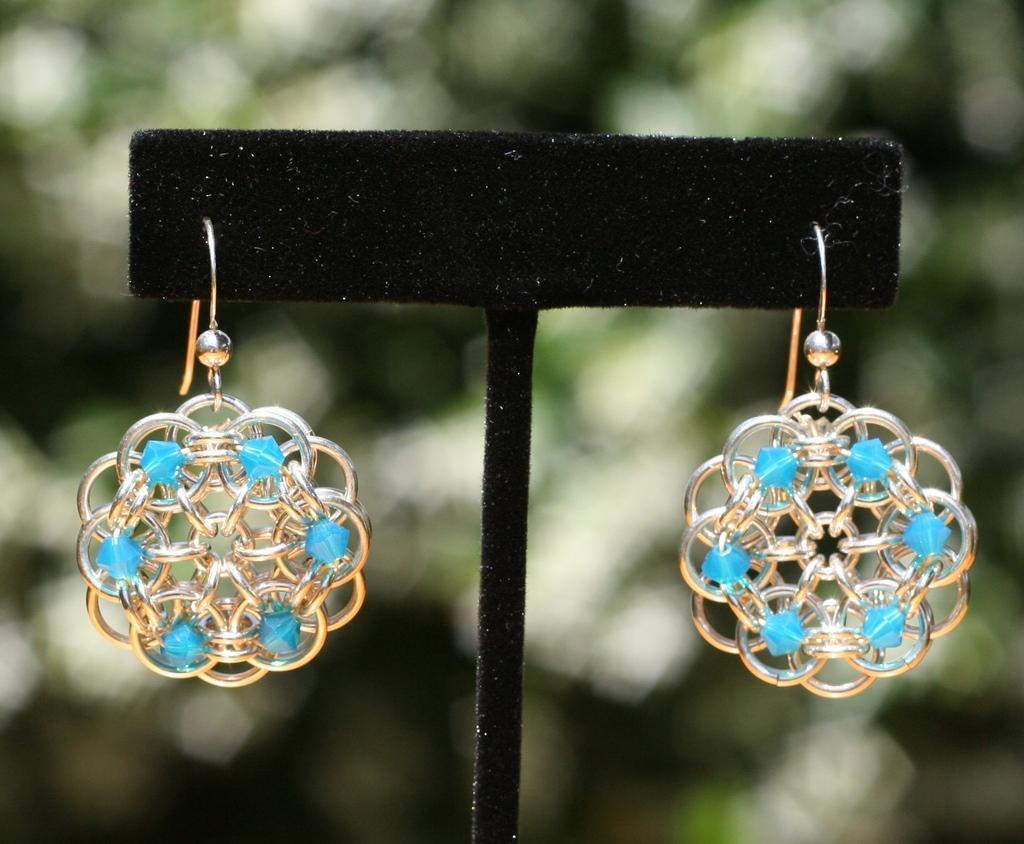Please provide a concise description of this image. In this image there is a small cardboard piece. There are earrings hanging to the cardboard. The background is blurry. 